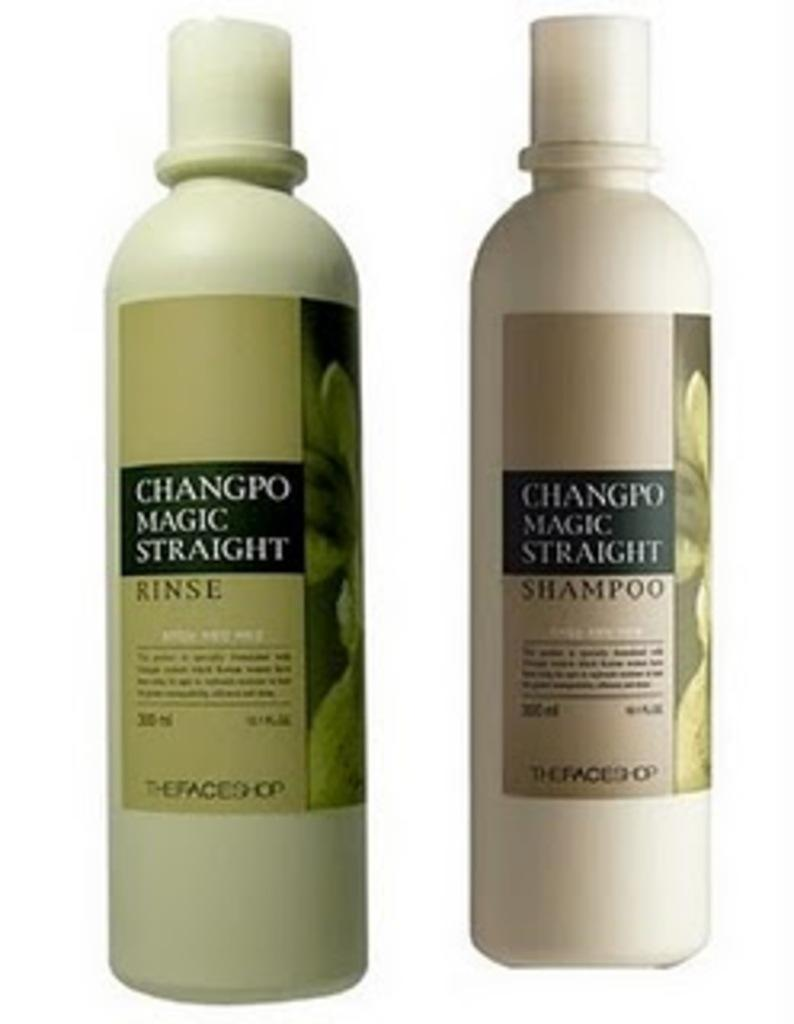Provide a one-sentence caption for the provided image. two bottles of changro magic straight shampoo and rinse. 